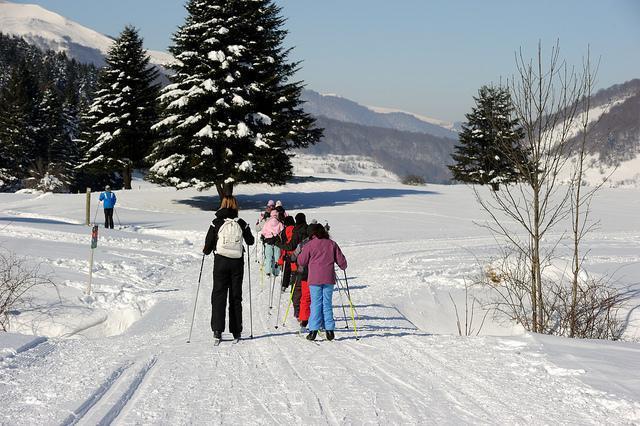How many white cars are on the road?
Give a very brief answer. 0. 